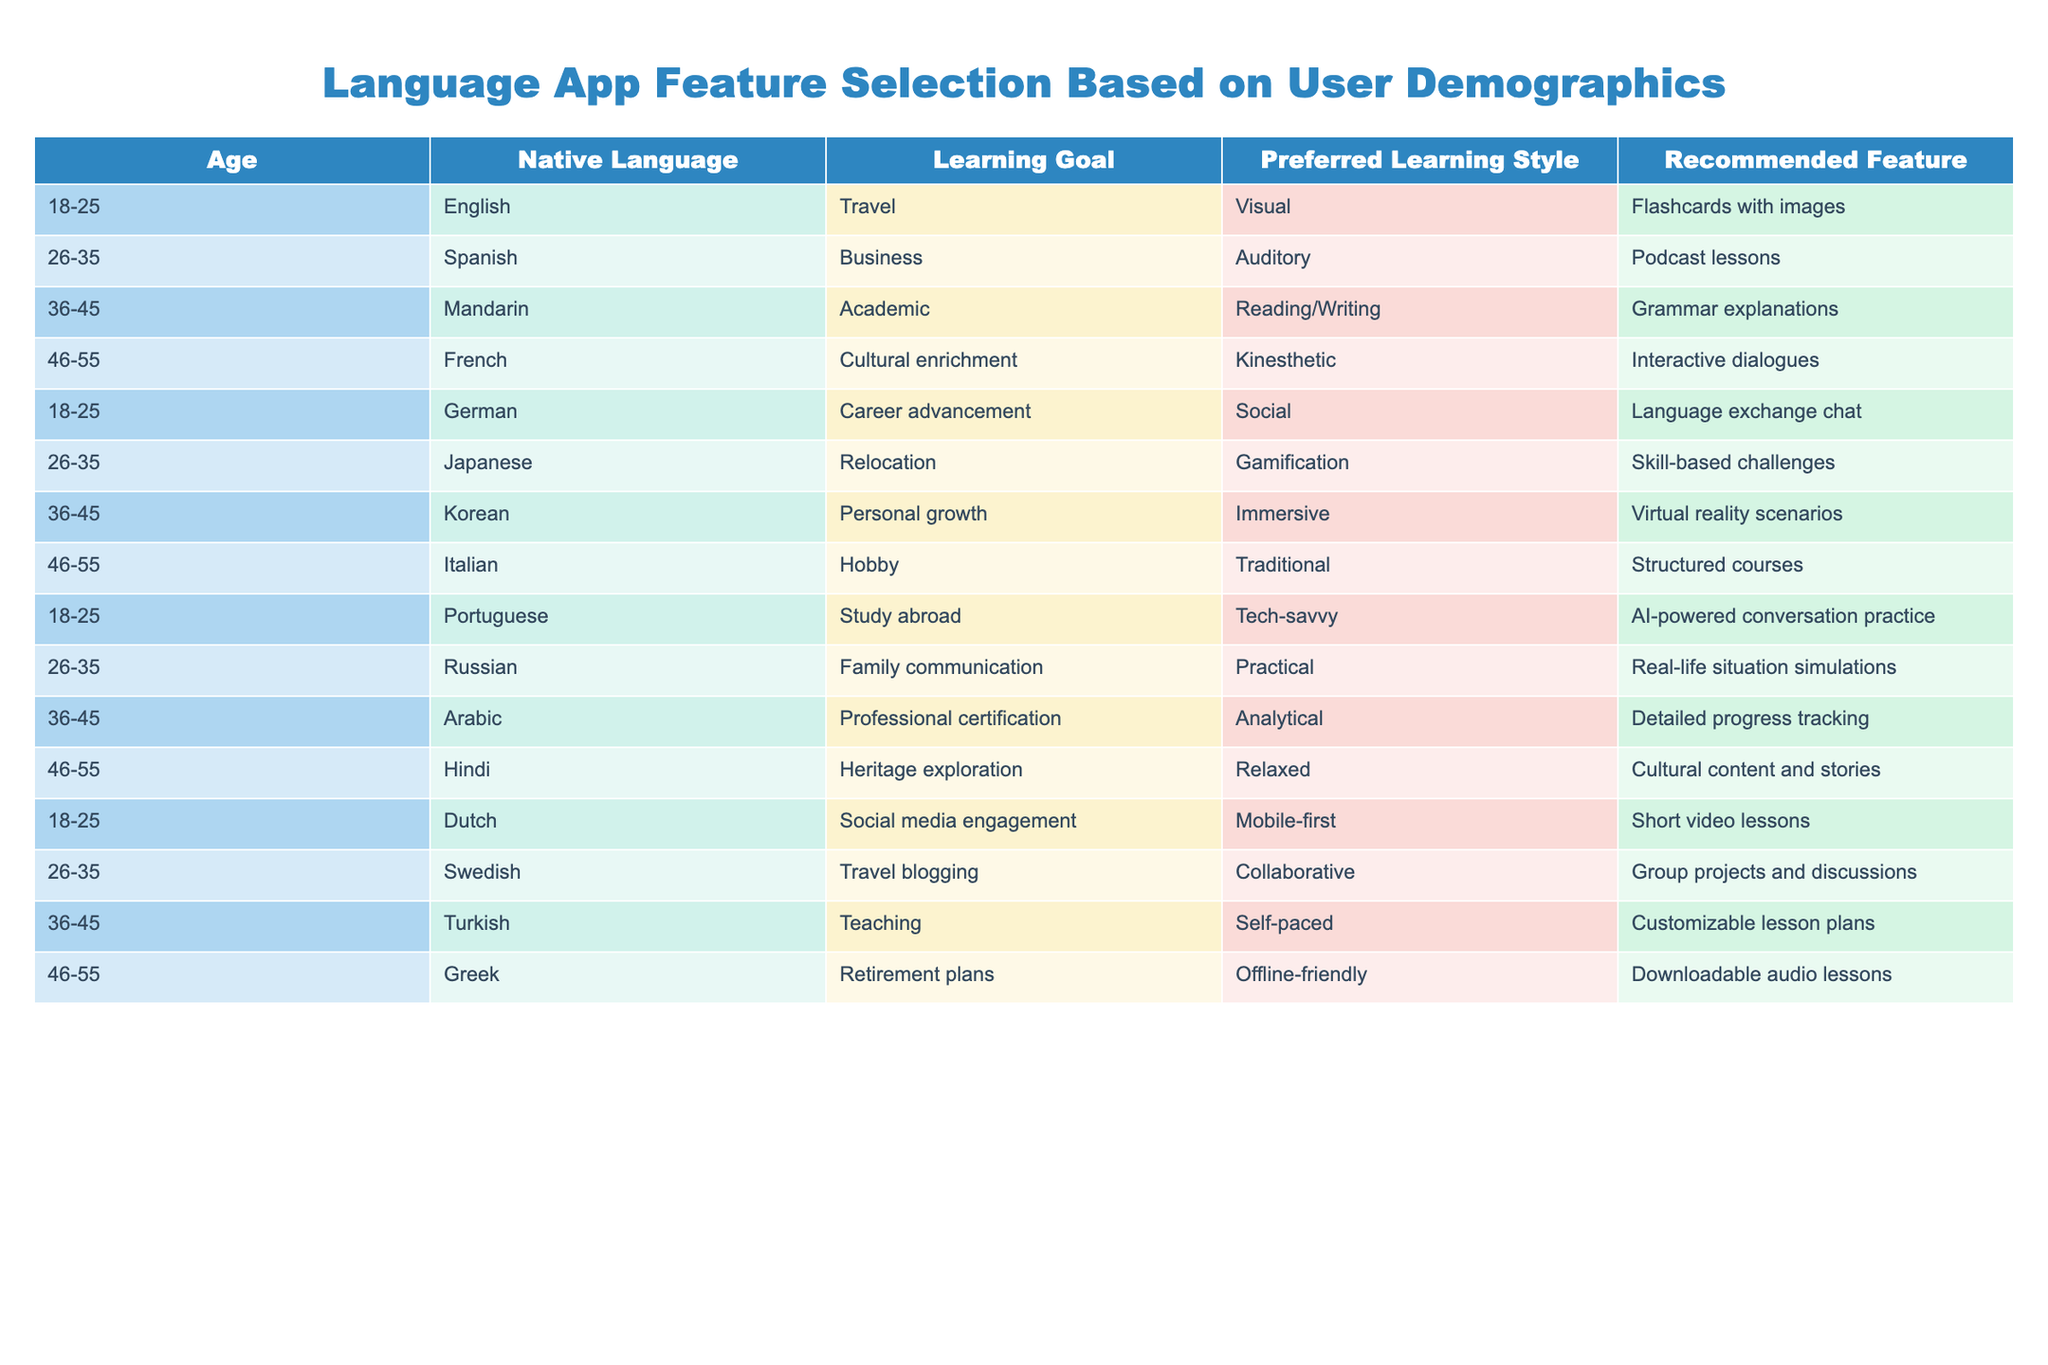What is the recommended feature for users aged 18-25 who want to learn for travel purposes? The table shows that for the age group 18-25, the recommended feature for users who have a learning goal of "Travel" is "Flashcards with images." This can be directly retrieved from the row where Age is "18-25," Native Language is "English," and Learning Goal is "Travel."
Answer: Flashcards with images Which learning style is preferred by users aged 26-35 who are focused on business? According to the table, the preferred learning style for users aged 26-35, whose learning goal is "Business," is "Auditory." This information can be found in the row corresponding to these demographic details.
Answer: Auditory How many different recommended features are there for the age group 46-55? To find this, we need to identify and count the unique recommended features listed for users aged 46-55. The table shows four rows for this age group, each with a different recommended feature: "Interactive dialogues," "Structured courses," "Downloadable audio lessons," and "Cultural content and stories." Therefore, there are four distinct recommended features.
Answer: 4 Are there any recommended features that cater to users wanting career advancement? By examining the table, we see that the recommended feature for "Career advancement" (occurring for users aged 18-25 who speak German) is "Language exchange chat." This specific feature is present, meaning the answer to the question is affirmative.
Answer: Yes What is the most common learning goal for users aged 36-45? Looking at the entries for the age group 36-45, we identify the learning goals: "Academic," "Personal growth," "Teaching," and "Professional certification." Each of these appears only once, meaning there is no single common goal shared by all users in this age group; rather, multiple goals exist. Thus, the answer is that there is no predominant goal.
Answer: No predominant goal 